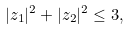Convert formula to latex. <formula><loc_0><loc_0><loc_500><loc_500>| z _ { 1 } | ^ { 2 } + | z _ { 2 } | ^ { 2 } \leq 3 ,</formula> 